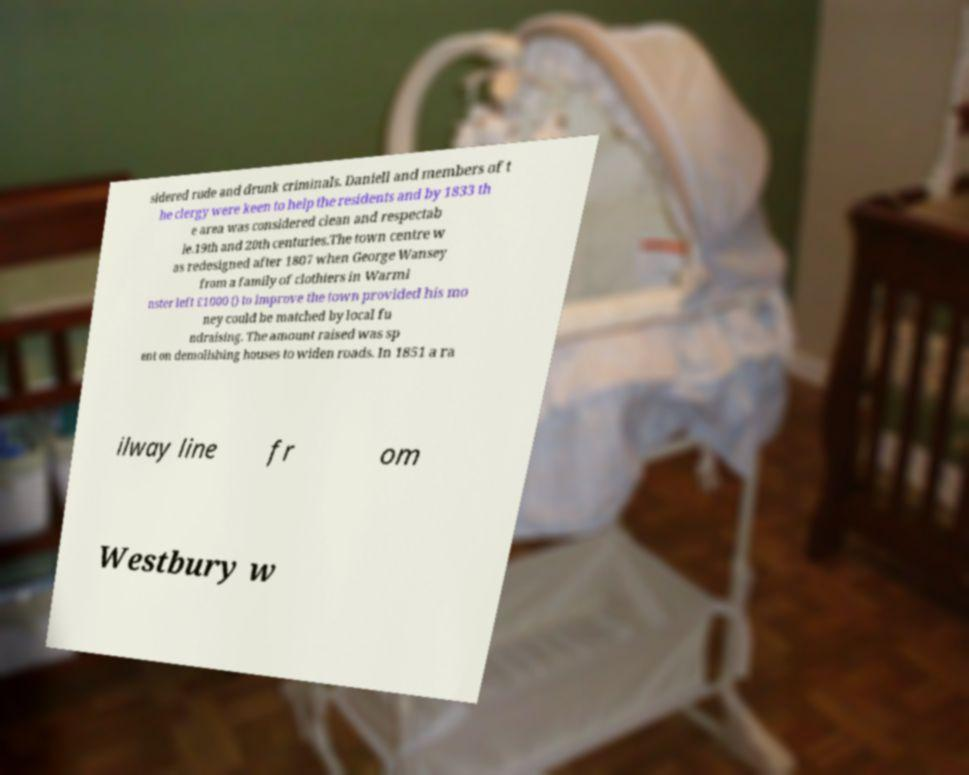Please read and relay the text visible in this image. What does it say? sidered rude and drunk criminals. Daniell and members of t he clergy were keen to help the residents and by 1833 th e area was considered clean and respectab le.19th and 20th centuries.The town centre w as redesigned after 1807 when George Wansey from a family of clothiers in Warmi nster left £1000 () to improve the town provided his mo ney could be matched by local fu ndraising. The amount raised was sp ent on demolishing houses to widen roads. In 1851 a ra ilway line fr om Westbury w 